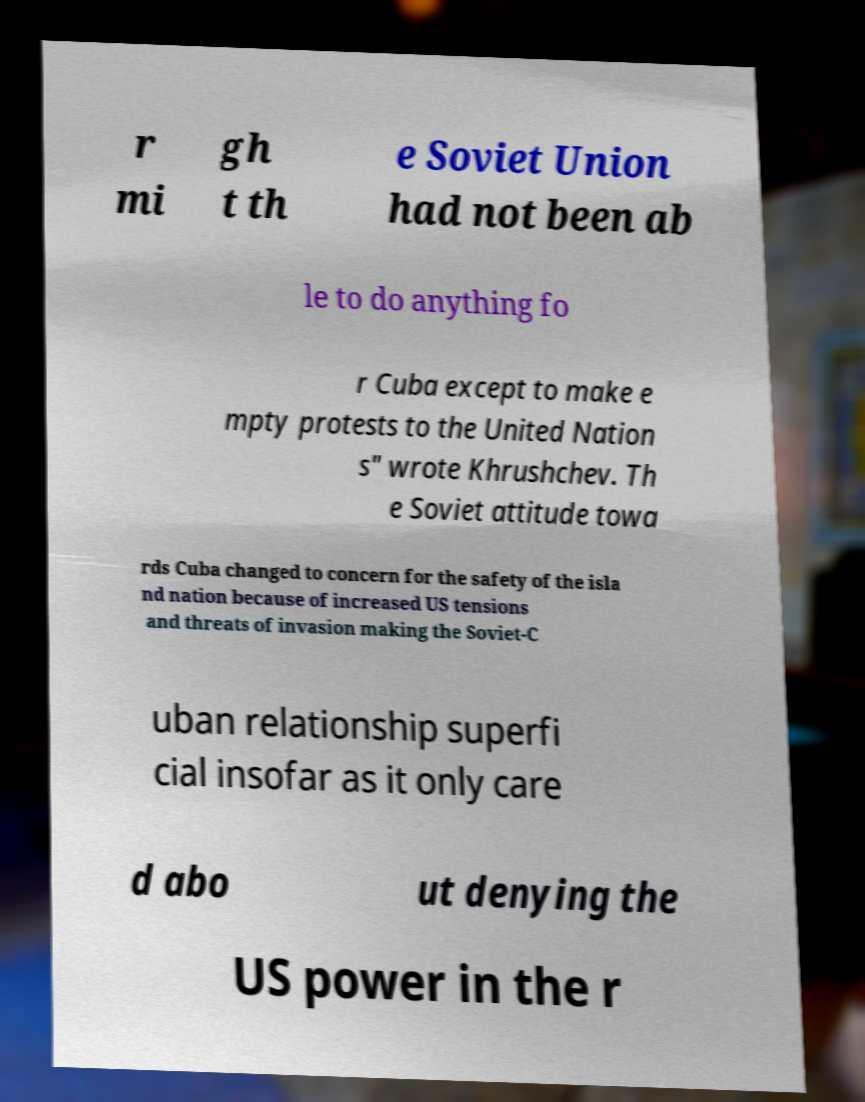Could you assist in decoding the text presented in this image and type it out clearly? r mi gh t th e Soviet Union had not been ab le to do anything fo r Cuba except to make e mpty protests to the United Nation s" wrote Khrushchev. Th e Soviet attitude towa rds Cuba changed to concern for the safety of the isla nd nation because of increased US tensions and threats of invasion making the Soviet-C uban relationship superfi cial insofar as it only care d abo ut denying the US power in the r 